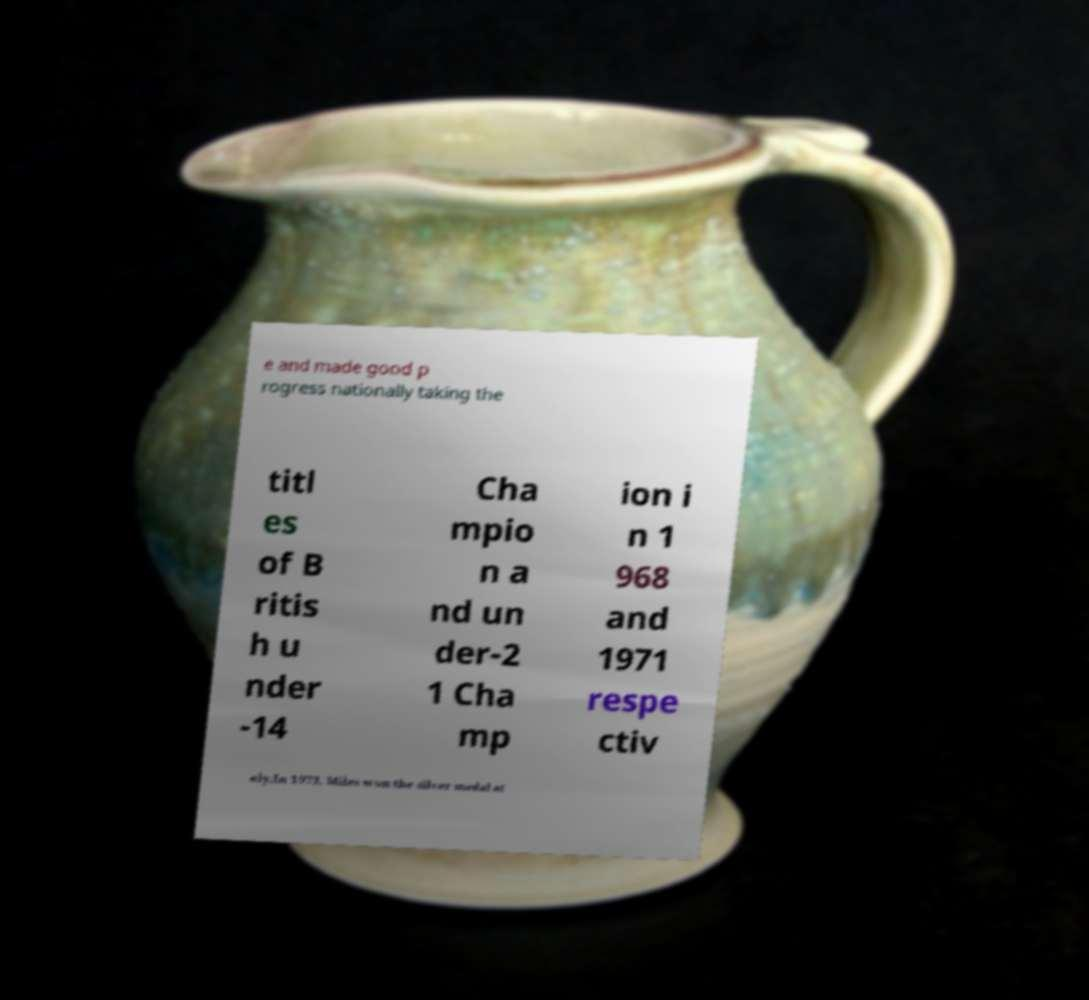Can you accurately transcribe the text from the provided image for me? e and made good p rogress nationally taking the titl es of B ritis h u nder -14 Cha mpio n a nd un der-2 1 Cha mp ion i n 1 968 and 1971 respe ctiv ely.In 1973, Miles won the silver medal at 